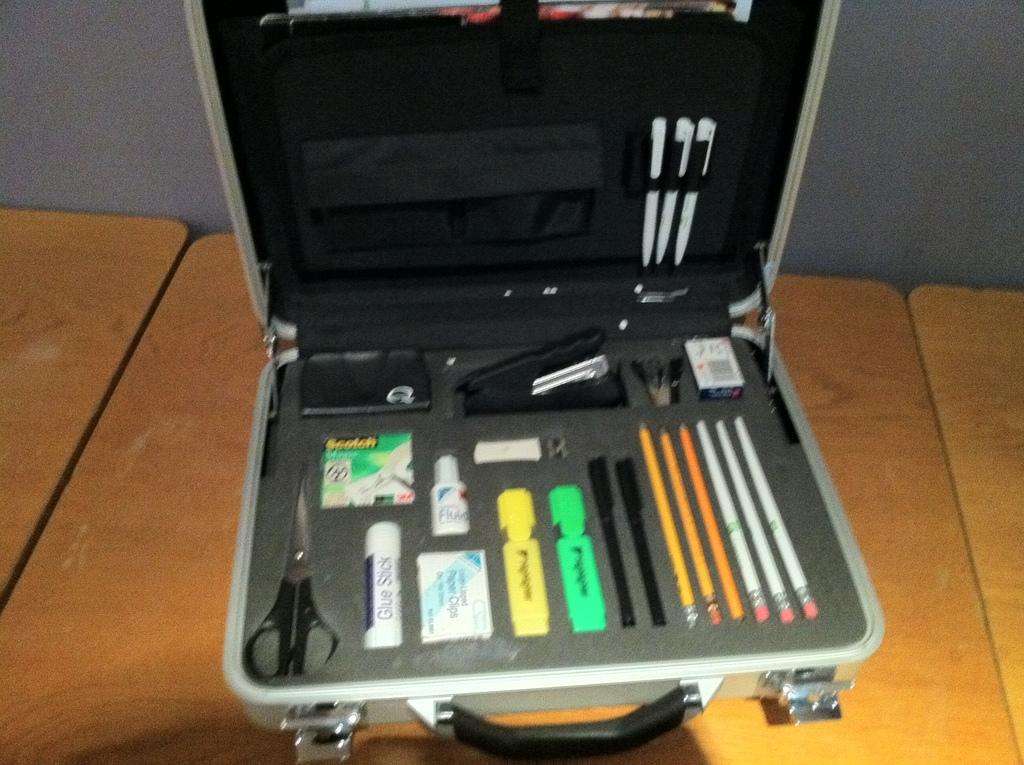What is the main object in the image? There is a box in the image. What items can be found inside the box? The box contains pencils, pens, scissors, a stapler, pins, and sketch pens. Is there any tool for sharpening in the box? Yes, a sharpener is placed in the box. What type of arithmetic problem can be solved using the items in the box? The items in the box are stationery supplies and do not relate to solving arithmetic problems. 